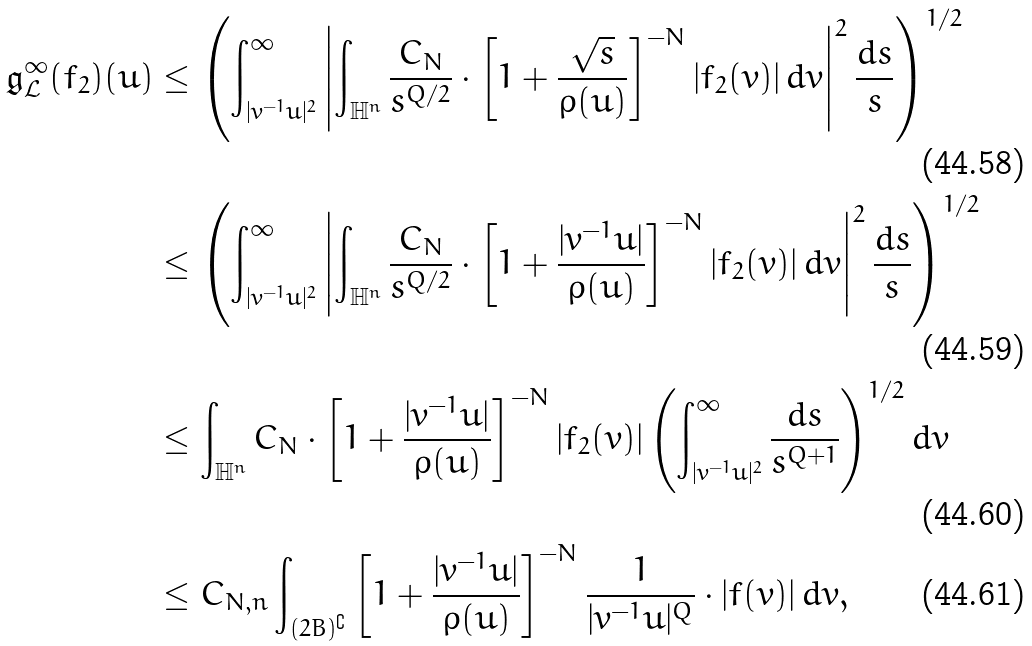<formula> <loc_0><loc_0><loc_500><loc_500>\mathfrak { g } _ { \mathcal { L } } ^ { \infty } ( f _ { 2 } ) ( u ) & \leq \left ( \int _ { | v ^ { - 1 } u | ^ { 2 } } ^ { \infty } \left | \int _ { \mathbb { H } ^ { n } } \frac { C _ { N } } { s ^ { Q / 2 } } \cdot \left [ 1 + \frac { \sqrt { s } } { \rho ( u ) } \right ] ^ { - N } | f _ { 2 } ( v ) | \, d v \right | ^ { 2 } \frac { d s } { s } \right ) ^ { 1 / 2 } \\ & \leq \left ( \int _ { | v ^ { - 1 } u | ^ { 2 } } ^ { \infty } \left | \int _ { \mathbb { H } ^ { n } } \frac { C _ { N } } { s ^ { Q / 2 } } \cdot \left [ 1 + \frac { | v ^ { - 1 } u | } { \rho ( u ) } \right ] ^ { - N } | f _ { 2 } ( v ) | \, d v \right | ^ { 2 } \frac { d s } { s } \right ) ^ { 1 / 2 } \\ & \leq \int _ { \mathbb { H } ^ { n } } C _ { N } \cdot \left [ 1 + \frac { | v ^ { - 1 } u | } { \rho ( u ) } \right ] ^ { - N } | f _ { 2 } ( v ) | \left ( \int _ { | v ^ { - 1 } u | ^ { 2 } } ^ { \infty } \frac { d s } { s ^ { Q + 1 } } \right ) ^ { 1 / 2 } d v \\ & \leq C _ { N , n } \int _ { ( 2 B ) ^ { \complement } } \left [ 1 + \frac { | v ^ { - 1 } u | } { \rho ( u ) } \right ] ^ { - N } \frac { 1 } { | v ^ { - 1 } u | ^ { Q } } \cdot | f ( v ) | \, d v ,</formula> 